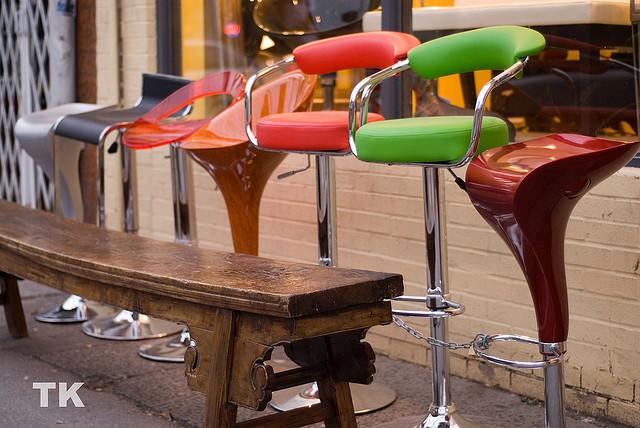What is the brown structure likely made of? wood 